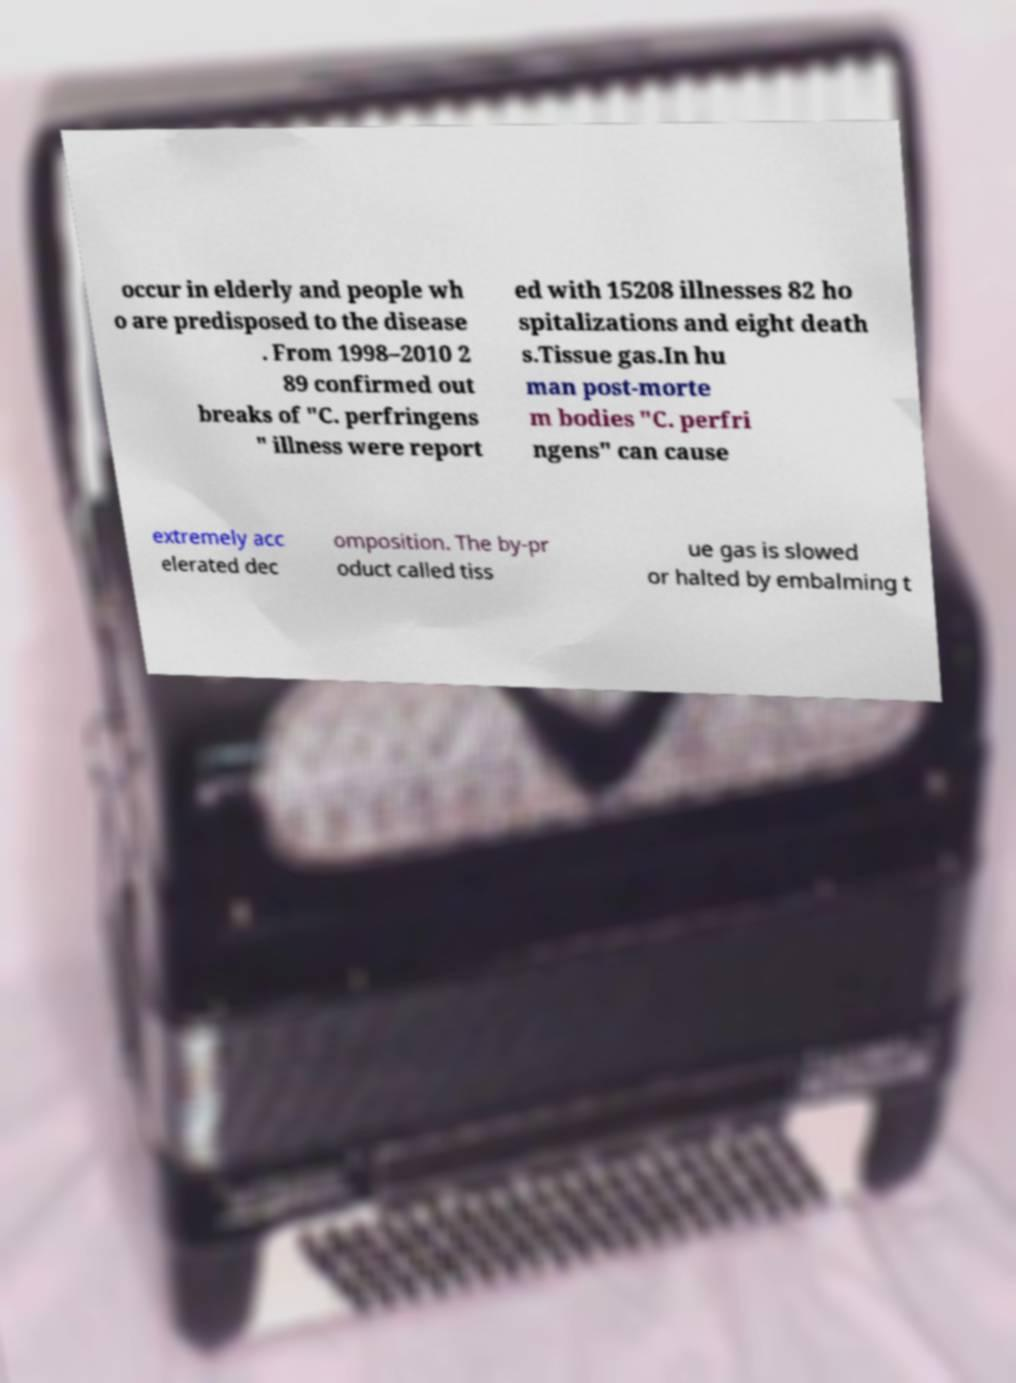Please identify and transcribe the text found in this image. occur in elderly and people wh o are predisposed to the disease . From 1998–2010 2 89 confirmed out breaks of "C. perfringens " illness were report ed with 15208 illnesses 82 ho spitalizations and eight death s.Tissue gas.In hu man post-morte m bodies "C. perfri ngens" can cause extremely acc elerated dec omposition. The by-pr oduct called tiss ue gas is slowed or halted by embalming t 